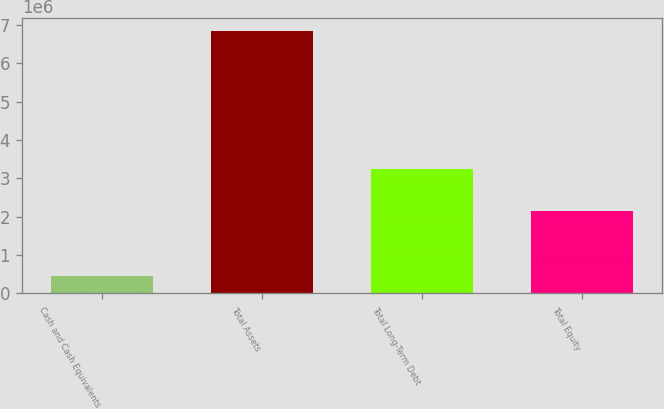Convert chart to OTSL. <chart><loc_0><loc_0><loc_500><loc_500><bar_chart><fcel>Cash and Cash Equivalents<fcel>Total Assets<fcel>Total Long-Term Debt<fcel>Total Equity<nl><fcel>446656<fcel>6.85116e+06<fcel>3.24865e+06<fcel>2.15076e+06<nl></chart> 